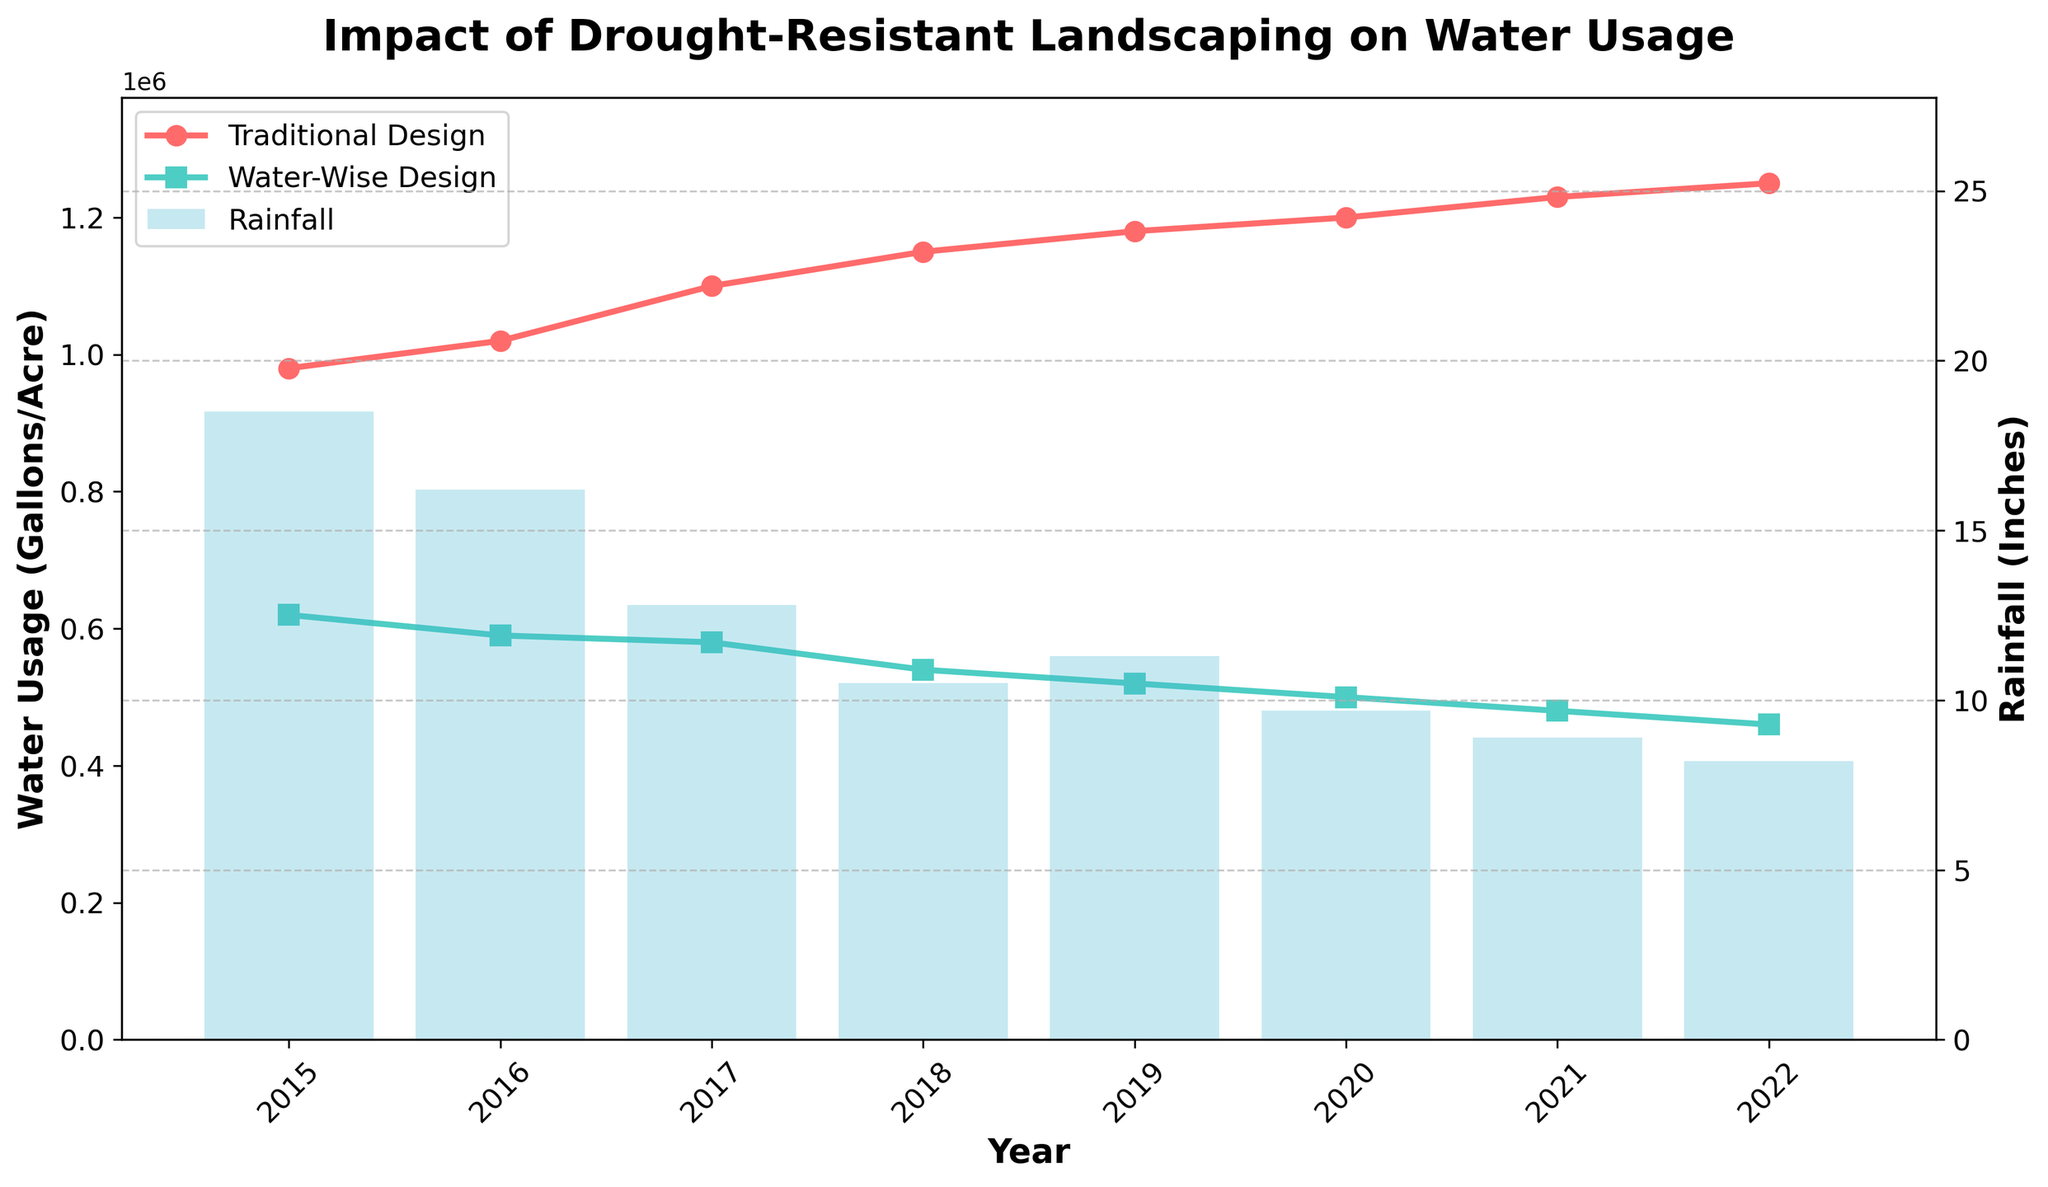Which year had the highest water usage for traditional design? To find the year with the highest water usage for traditional design, look for the peak value in the red line plot. In this case, the value reaches its maximum at 2022.
Answer: 2022 What is the difference in water usage between traditional and water-wise designs in 2022? First, find the values for traditional and water-wise designs in 2022, which are 1,250,000 and 460,000 gallons/acre, respectively. Subtract the water-wise value from the traditional value: 1,250,000 - 460,000 = 790,000 gallons/acre.
Answer: 790,000 gallons/acre How has the water usage trend in traditional design changed from 2015 to 2022? To understand the trend, observe the red line's direction from 2015 to 2022. The water usage for traditional design has generally increased over the years, moving from 980,000 gallons/acre in 2015 to 1,250,000 gallons/acre in 2022.
Answer: Increased By how much did rainfall decrease from 2015 to 2022? Identify the rainfall values for 2015 and 2022, which are 18.5 inches and 8.2 inches respectively. Subtract the 2022 value from the 2015 value: 18.5 - 8.2 = 10.3 inches.
Answer: 10.3 inches What is the average water usage for water-wise design from 2015 to 2022? Sum the water usage values for water-wise design from 2015 to 2022 and then divide by the number of years. So, (620,000 + 590,000 + 580,000 + 540,000 + 520,000 + 500,000 + 480,000 + 460,000) / 8 = 536,250 gallons/acre.
Answer: 536,250 gallons/acre For which years was rainfall below 10 inches? Check the years where the blue bars indicating rainfall are lower than the 10-inch mark. These years are 2018, 2020, 2021, and 2022.
Answer: 2018, 2020, 2021, 2022 In which year was the difference in water usage between traditional and water-wise designs the smallest? Calculate the difference for each year and find the minimum value. By comparing, the smallest difference is in 2017 (110,000 gallons/acre).
Answer: 2017 How does the water usage in 2020 compare for traditional and water-wise designs? Compare the heights of the red and green lines for 2020. The traditional design is at 1,200,000 gallons/acre, while the water-wise design is at 500,000 gallons/acre. Hence, traditional design uses substantially more water.
Answer: Traditional design uses more What is the median rainfall from 2015 to 2022? List the rainfall values and find the middle value. The rainfall values are 18.5, 16.2, 12.8, 10.5, 11.3, 9.7, 8.9, and 8.2. First, order them: 8.2, 8.9, 9.7, 10.5, 11.3, 12.8, 16.2, 18.5. The middle two values are 10.5 and 11.3, so the median is (10.5 + 11.3) / 2 = 10.9 inches.
Answer: 10.9 inches Which design had a smaller percentage change in water usage from 2015 to 2022? Calculate the percentage change for both designs: 
Traditional: ((1,250,000 - 980,000) / 980,000) * 100 = 27.55%
Water-wise: ((460,000 - 620,000) / 620,000) * 100 = -25.81%
The water-wise design had a smaller percentage change.
Answer: Water-wise design 